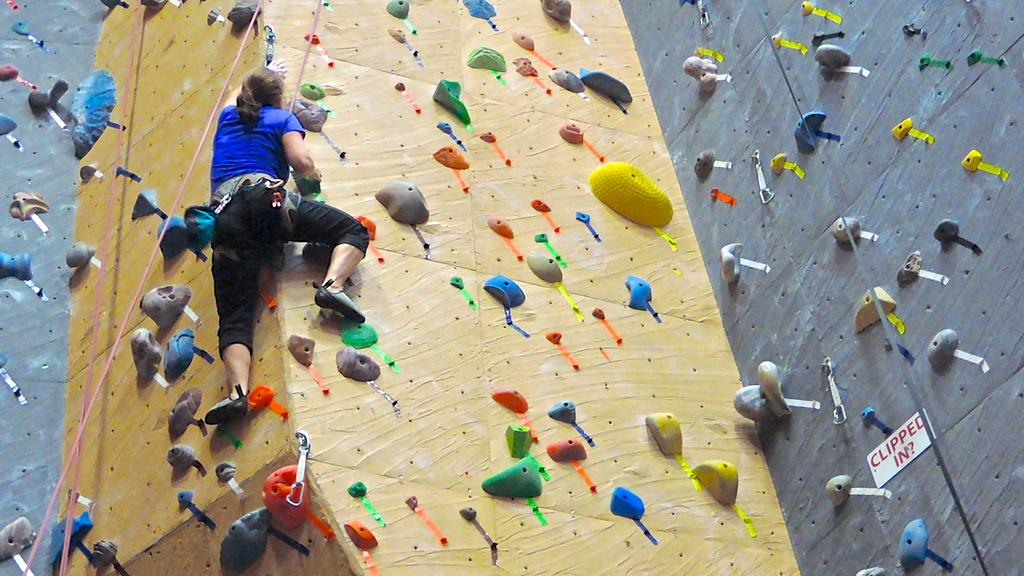Who is the main subject in the image? There is a person in the image. What is the person doing in the image? The person is climbing a wall. What tools or equipment are being used by the person in the image? There are ropes visible in the image. What is attached to the wall in the image? There is a board attached to the wall in the image. What word is written on the square in the image? There is no square or word present in the image. 